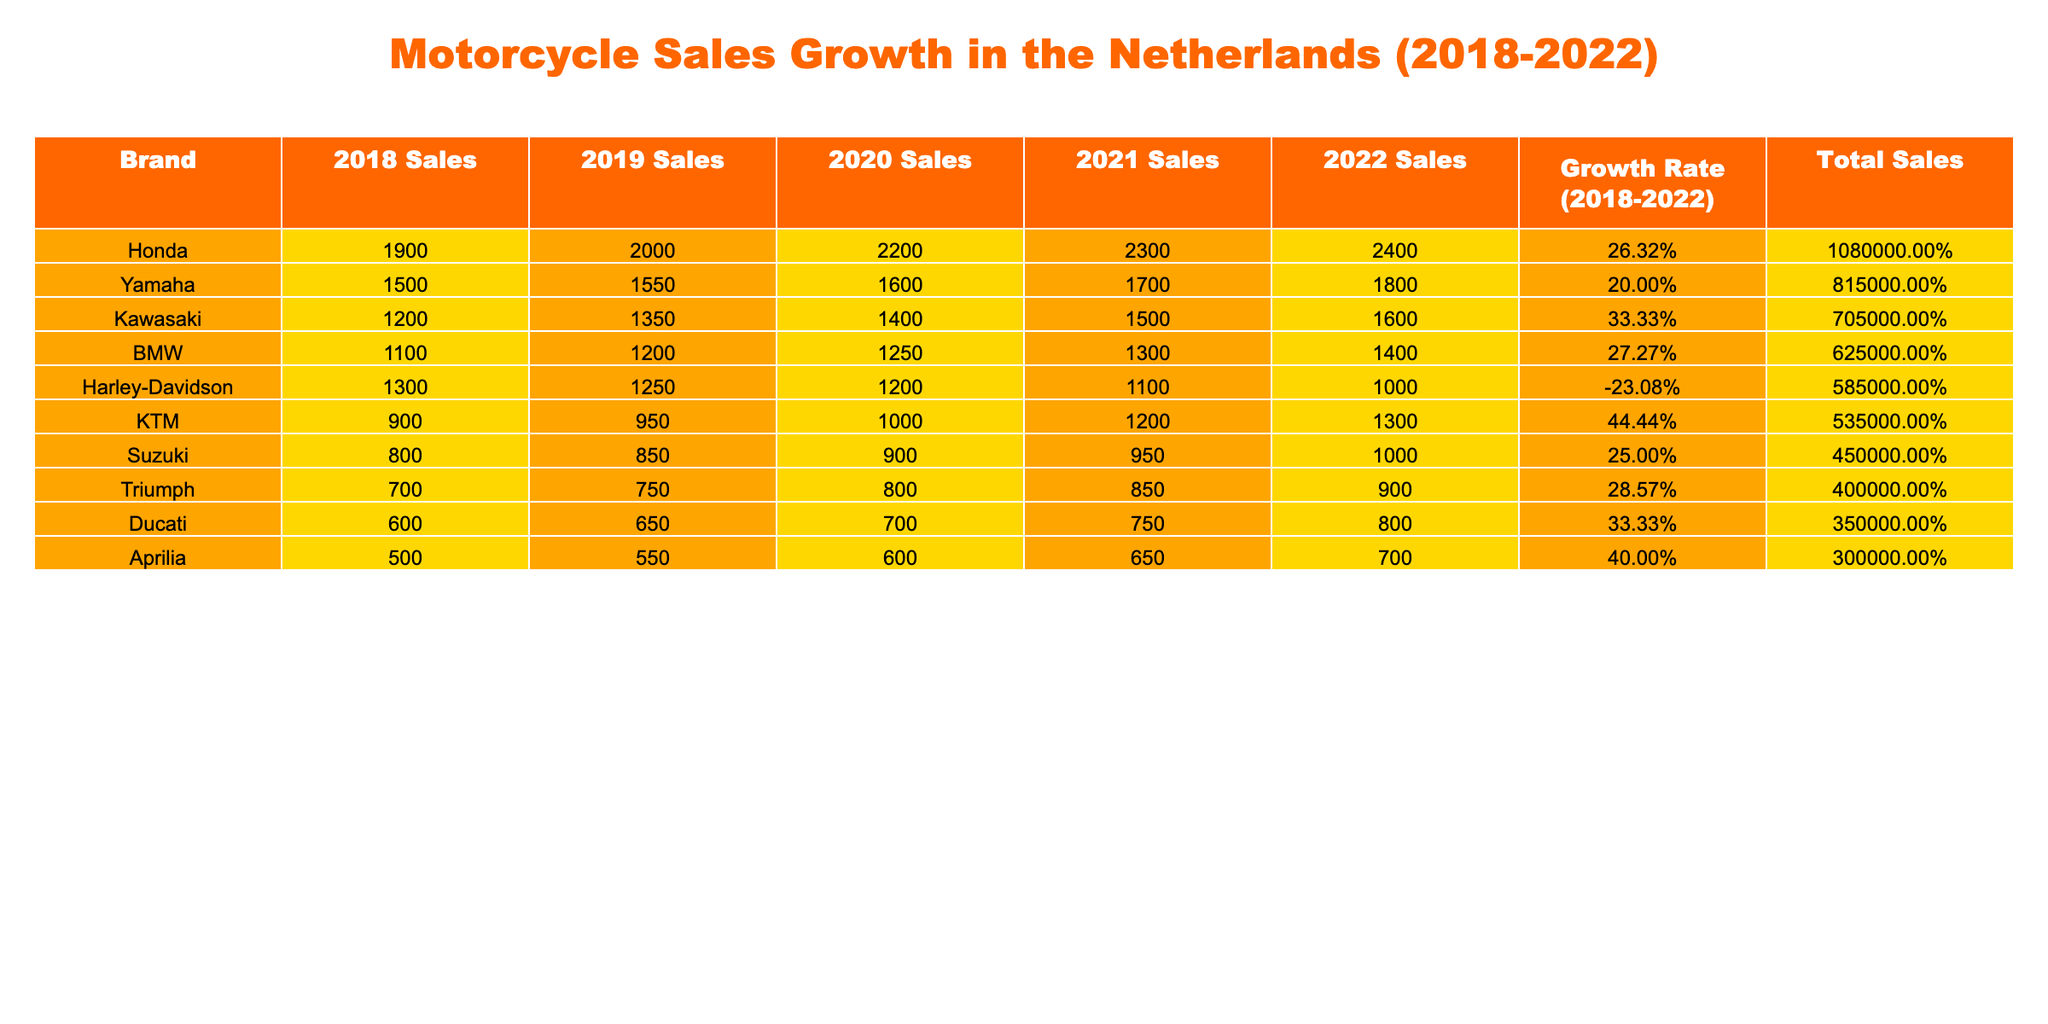What brand had the highest sales in 2022? Looking at the 2022 Sales column, Honda has the highest value with 2400 units sold.
Answer: Honda What was the growth rate of Harley-Davidson from 2018 to 2022? The table shows that Harley-Davidson had a growth rate of -23.08% from 2018 to 2022, indicating a decline in sales over the years.
Answer: -23.08% Which brand had the lowest sales in 2019? In the 2019 Sales column, Aprilia had the lowest sales with 550 units sold compared to other brands.
Answer: Aprilia What are the total sales of Ducati from 2018 to 2022? To find the total sales, sum the values: 600 + 650 + 700 + 750 + 800 = 3500.
Answer: 3500 Which brand showed the highest growth rate from 2018 to 2022? KTM had the highest growth rate of 44.44%, as indicated in the Growth Rate column.
Answer: KTM Did Yamaha's sales increase every year from 2018 to 2022? Yes, by examining the annual sales values for Yamaha (1500, 1550, 1600, 1700, 1800), it shows a continuous increase each year.
Answer: Yes What is the difference in total sales between Kawasaki and BMW from 2018 to 2022? Calculate Kawasaki's total sales: 1200 + 1350 + 1400 + 1500 + 1600 = 7050. For BMW: 1100 + 1200 + 1250 + 1300 + 1400 = 6250. The difference is 7050 - 6250 = 800.
Answer: 800 What was the total sales of all brands combined in 2020? To find the total for 2020, add all sales: 1400 (Kawasaki) + 1600 (Yamaha) + 2200 (Honda) + 900 (Suzuki) + 700 (Ducati) + 1250 (BMW) + 1000 (KTM) + 1200 (Harley-Davidson) + 600 (Aprilia) + 800 (Triumph) = 11600.
Answer: 11600 How many brands had a growth rate greater than 30%? The growth rates are 33.33% (Kawasaki and Ducati), 44.44% (KTM), and 40% (Aprilia). Therefore, a total of 4 brands (Kawasaki, Ducati, KTM, and Aprilia) had growth rates above 30%.
Answer: 4 What percentage of the total sales in 2022 does Honda represent? The total sales in 2022 for all brands: 1600 (Kawasaki) + 1800 (Yamaha) + 2400 (Honda) + 1000 (Suzuki) + 800 (Ducati) + 1400 (BMW) + 1300 (KTM) + 1000 (Harley-Davidson) + 700 (Aprilia) + 900 (Triumph) = 13800. Honda's sales are 2400, so the percentage is (2400 / 13800) x 100 = 17.39%.
Answer: 17.39% 